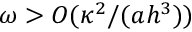<formula> <loc_0><loc_0><loc_500><loc_500>\omega > O ( \kappa ^ { 2 } / ( a h ^ { 3 } ) )</formula> 